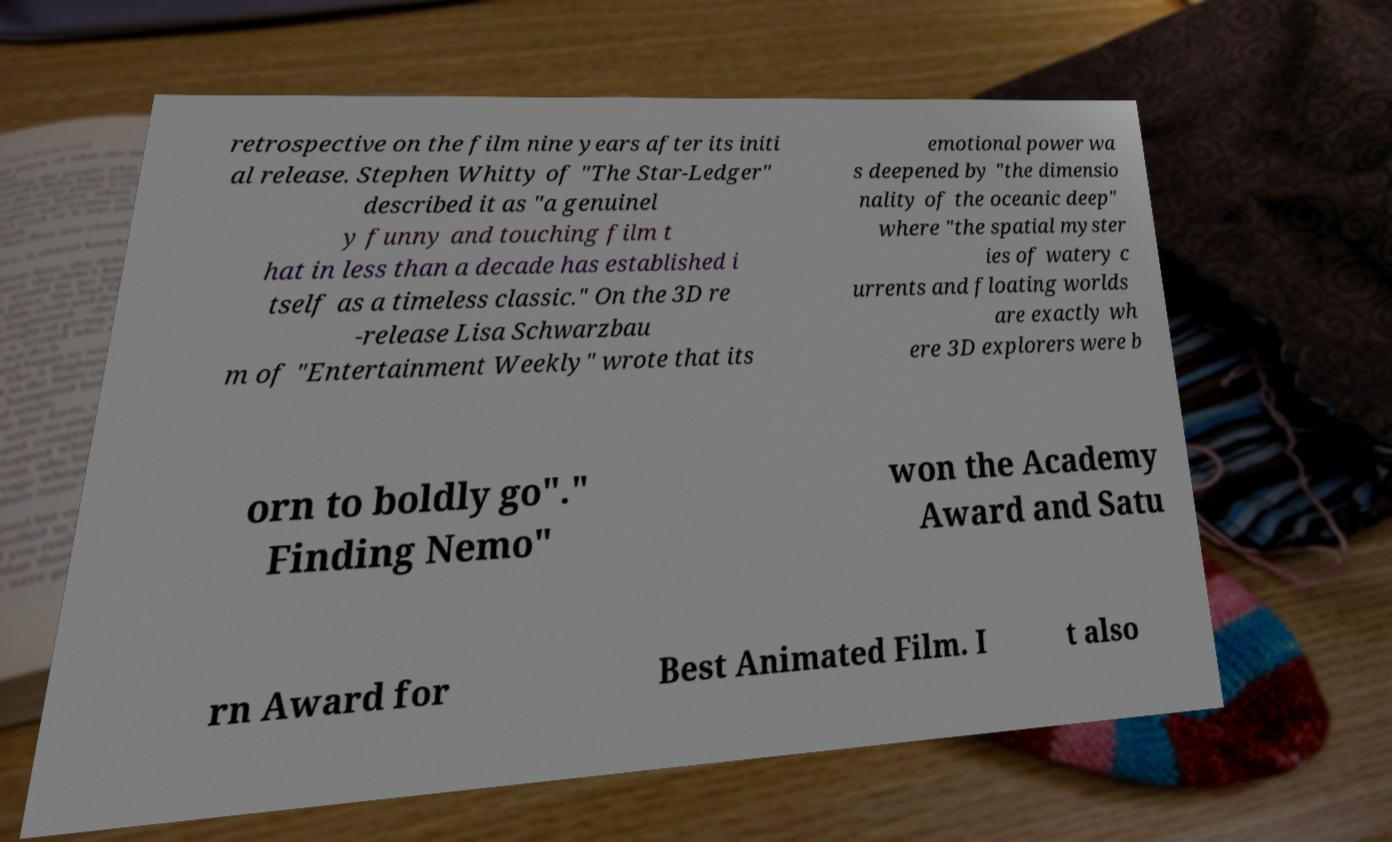Can you accurately transcribe the text from the provided image for me? retrospective on the film nine years after its initi al release. Stephen Whitty of "The Star-Ledger" described it as "a genuinel y funny and touching film t hat in less than a decade has established i tself as a timeless classic." On the 3D re -release Lisa Schwarzbau m of "Entertainment Weekly" wrote that its emotional power wa s deepened by "the dimensio nality of the oceanic deep" where "the spatial myster ies of watery c urrents and floating worlds are exactly wh ere 3D explorers were b orn to boldly go"." Finding Nemo" won the Academy Award and Satu rn Award for Best Animated Film. I t also 